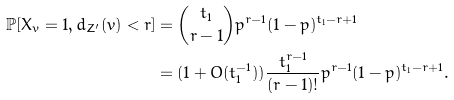Convert formula to latex. <formula><loc_0><loc_0><loc_500><loc_500>\mathbb { P } [ X _ { v } = 1 , d _ { Z ^ { \prime } } ( v ) < r ] & = \binom { t _ { 1 } } { r - 1 } p ^ { r - 1 } ( 1 - p ) ^ { t _ { 1 } - r + 1 } \\ & = ( 1 + O ( t _ { 1 } ^ { - 1 } ) ) \frac { t _ { 1 } ^ { r - 1 } } { ( r - 1 ) ! } p ^ { r - 1 } ( 1 - p ) ^ { t _ { 1 } - r + 1 } .</formula> 